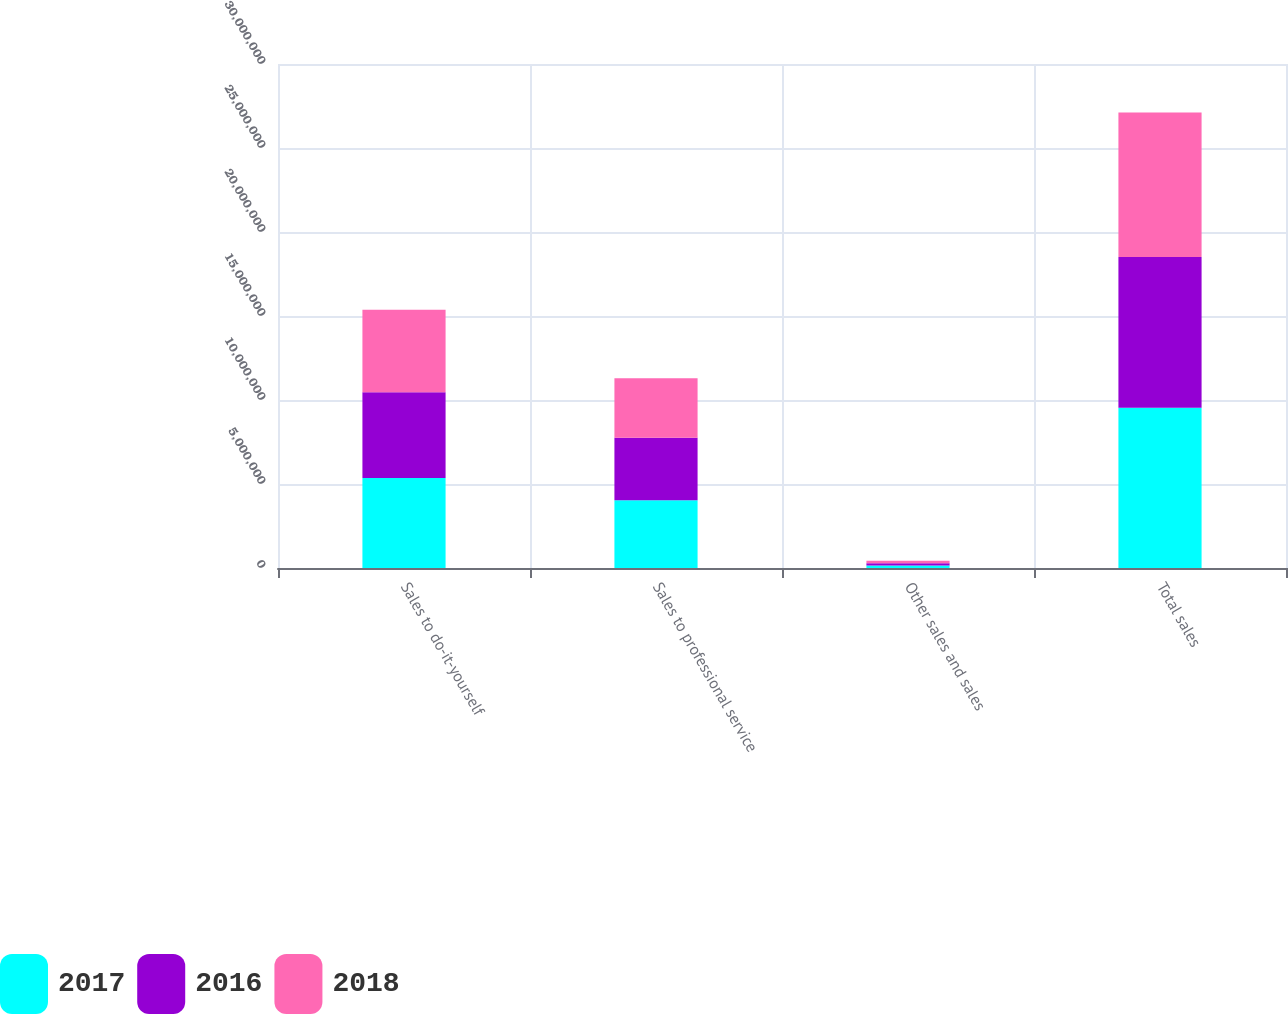Convert chart to OTSL. <chart><loc_0><loc_0><loc_500><loc_500><stacked_bar_chart><ecel><fcel>Sales to do-it-yourself<fcel>Sales to professional service<fcel>Other sales and sales<fcel>Total sales<nl><fcel>2017<fcel>5.35104e+06<fcel>4.0359e+06<fcel>149495<fcel>9.53643e+06<nl><fcel>2016<fcel>5.11329e+06<fcel>3.72422e+06<fcel>140218<fcel>8.97773e+06<nl><fcel>2018<fcel>4.91183e+06<fcel>3.54012e+06<fcel>141154<fcel>8.5931e+06<nl></chart> 